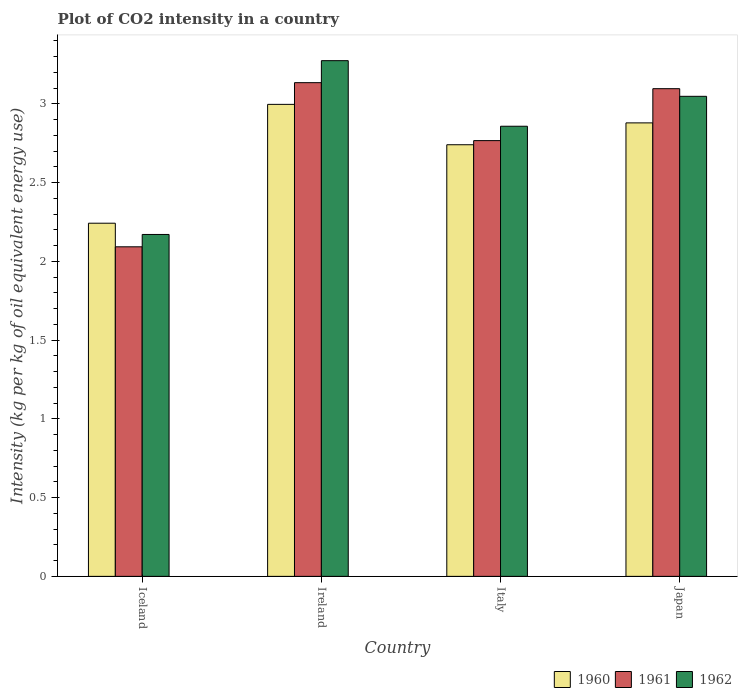How many different coloured bars are there?
Ensure brevity in your answer.  3. How many groups of bars are there?
Provide a short and direct response. 4. Are the number of bars per tick equal to the number of legend labels?
Your answer should be very brief. Yes. Are the number of bars on each tick of the X-axis equal?
Ensure brevity in your answer.  Yes. How many bars are there on the 2nd tick from the right?
Ensure brevity in your answer.  3. What is the label of the 4th group of bars from the left?
Ensure brevity in your answer.  Japan. In how many cases, is the number of bars for a given country not equal to the number of legend labels?
Keep it short and to the point. 0. What is the CO2 intensity in in 1962 in Japan?
Offer a very short reply. 3.05. Across all countries, what is the maximum CO2 intensity in in 1961?
Give a very brief answer. 3.14. Across all countries, what is the minimum CO2 intensity in in 1960?
Keep it short and to the point. 2.24. In which country was the CO2 intensity in in 1960 maximum?
Your answer should be very brief. Ireland. In which country was the CO2 intensity in in 1960 minimum?
Provide a short and direct response. Iceland. What is the total CO2 intensity in in 1962 in the graph?
Keep it short and to the point. 11.35. What is the difference between the CO2 intensity in in 1960 in Iceland and that in Italy?
Offer a very short reply. -0.5. What is the difference between the CO2 intensity in in 1960 in Japan and the CO2 intensity in in 1961 in Ireland?
Keep it short and to the point. -0.26. What is the average CO2 intensity in in 1960 per country?
Ensure brevity in your answer.  2.72. What is the difference between the CO2 intensity in of/in 1962 and CO2 intensity in of/in 1960 in Iceland?
Keep it short and to the point. -0.07. In how many countries, is the CO2 intensity in in 1960 greater than 1.8 kg?
Ensure brevity in your answer.  4. What is the ratio of the CO2 intensity in in 1960 in Ireland to that in Japan?
Ensure brevity in your answer.  1.04. What is the difference between the highest and the second highest CO2 intensity in in 1960?
Offer a terse response. 0.12. What is the difference between the highest and the lowest CO2 intensity in in 1960?
Provide a short and direct response. 0.75. Is the sum of the CO2 intensity in in 1960 in Iceland and Italy greater than the maximum CO2 intensity in in 1961 across all countries?
Your response must be concise. Yes. What does the 2nd bar from the left in Italy represents?
Make the answer very short. 1961. Is it the case that in every country, the sum of the CO2 intensity in in 1960 and CO2 intensity in in 1961 is greater than the CO2 intensity in in 1962?
Give a very brief answer. Yes. Are all the bars in the graph horizontal?
Offer a terse response. No. How many countries are there in the graph?
Provide a succinct answer. 4. Does the graph contain grids?
Offer a terse response. No. Where does the legend appear in the graph?
Your answer should be very brief. Bottom right. How are the legend labels stacked?
Your answer should be very brief. Horizontal. What is the title of the graph?
Provide a short and direct response. Plot of CO2 intensity in a country. What is the label or title of the Y-axis?
Your response must be concise. Intensity (kg per kg of oil equivalent energy use). What is the Intensity (kg per kg of oil equivalent energy use) in 1960 in Iceland?
Provide a short and direct response. 2.24. What is the Intensity (kg per kg of oil equivalent energy use) in 1961 in Iceland?
Your answer should be compact. 2.09. What is the Intensity (kg per kg of oil equivalent energy use) of 1962 in Iceland?
Provide a short and direct response. 2.17. What is the Intensity (kg per kg of oil equivalent energy use) of 1960 in Ireland?
Provide a short and direct response. 3. What is the Intensity (kg per kg of oil equivalent energy use) in 1961 in Ireland?
Make the answer very short. 3.14. What is the Intensity (kg per kg of oil equivalent energy use) in 1962 in Ireland?
Keep it short and to the point. 3.27. What is the Intensity (kg per kg of oil equivalent energy use) in 1960 in Italy?
Give a very brief answer. 2.74. What is the Intensity (kg per kg of oil equivalent energy use) of 1961 in Italy?
Ensure brevity in your answer.  2.77. What is the Intensity (kg per kg of oil equivalent energy use) in 1962 in Italy?
Keep it short and to the point. 2.86. What is the Intensity (kg per kg of oil equivalent energy use) in 1960 in Japan?
Provide a succinct answer. 2.88. What is the Intensity (kg per kg of oil equivalent energy use) of 1961 in Japan?
Your response must be concise. 3.1. What is the Intensity (kg per kg of oil equivalent energy use) of 1962 in Japan?
Keep it short and to the point. 3.05. Across all countries, what is the maximum Intensity (kg per kg of oil equivalent energy use) of 1960?
Your answer should be compact. 3. Across all countries, what is the maximum Intensity (kg per kg of oil equivalent energy use) of 1961?
Provide a short and direct response. 3.14. Across all countries, what is the maximum Intensity (kg per kg of oil equivalent energy use) in 1962?
Give a very brief answer. 3.27. Across all countries, what is the minimum Intensity (kg per kg of oil equivalent energy use) in 1960?
Make the answer very short. 2.24. Across all countries, what is the minimum Intensity (kg per kg of oil equivalent energy use) of 1961?
Your response must be concise. 2.09. Across all countries, what is the minimum Intensity (kg per kg of oil equivalent energy use) of 1962?
Your answer should be compact. 2.17. What is the total Intensity (kg per kg of oil equivalent energy use) of 1960 in the graph?
Your answer should be very brief. 10.86. What is the total Intensity (kg per kg of oil equivalent energy use) in 1961 in the graph?
Ensure brevity in your answer.  11.09. What is the total Intensity (kg per kg of oil equivalent energy use) of 1962 in the graph?
Keep it short and to the point. 11.35. What is the difference between the Intensity (kg per kg of oil equivalent energy use) in 1960 in Iceland and that in Ireland?
Provide a short and direct response. -0.75. What is the difference between the Intensity (kg per kg of oil equivalent energy use) in 1961 in Iceland and that in Ireland?
Your answer should be very brief. -1.04. What is the difference between the Intensity (kg per kg of oil equivalent energy use) of 1962 in Iceland and that in Ireland?
Ensure brevity in your answer.  -1.1. What is the difference between the Intensity (kg per kg of oil equivalent energy use) in 1960 in Iceland and that in Italy?
Offer a terse response. -0.5. What is the difference between the Intensity (kg per kg of oil equivalent energy use) of 1961 in Iceland and that in Italy?
Ensure brevity in your answer.  -0.67. What is the difference between the Intensity (kg per kg of oil equivalent energy use) in 1962 in Iceland and that in Italy?
Your response must be concise. -0.69. What is the difference between the Intensity (kg per kg of oil equivalent energy use) in 1960 in Iceland and that in Japan?
Give a very brief answer. -0.64. What is the difference between the Intensity (kg per kg of oil equivalent energy use) in 1961 in Iceland and that in Japan?
Give a very brief answer. -1. What is the difference between the Intensity (kg per kg of oil equivalent energy use) of 1962 in Iceland and that in Japan?
Provide a short and direct response. -0.88. What is the difference between the Intensity (kg per kg of oil equivalent energy use) in 1960 in Ireland and that in Italy?
Your answer should be compact. 0.26. What is the difference between the Intensity (kg per kg of oil equivalent energy use) of 1961 in Ireland and that in Italy?
Your response must be concise. 0.37. What is the difference between the Intensity (kg per kg of oil equivalent energy use) in 1962 in Ireland and that in Italy?
Provide a succinct answer. 0.42. What is the difference between the Intensity (kg per kg of oil equivalent energy use) in 1960 in Ireland and that in Japan?
Give a very brief answer. 0.12. What is the difference between the Intensity (kg per kg of oil equivalent energy use) in 1961 in Ireland and that in Japan?
Ensure brevity in your answer.  0.04. What is the difference between the Intensity (kg per kg of oil equivalent energy use) in 1962 in Ireland and that in Japan?
Provide a short and direct response. 0.23. What is the difference between the Intensity (kg per kg of oil equivalent energy use) of 1960 in Italy and that in Japan?
Your answer should be compact. -0.14. What is the difference between the Intensity (kg per kg of oil equivalent energy use) of 1961 in Italy and that in Japan?
Provide a short and direct response. -0.33. What is the difference between the Intensity (kg per kg of oil equivalent energy use) in 1962 in Italy and that in Japan?
Provide a succinct answer. -0.19. What is the difference between the Intensity (kg per kg of oil equivalent energy use) in 1960 in Iceland and the Intensity (kg per kg of oil equivalent energy use) in 1961 in Ireland?
Give a very brief answer. -0.89. What is the difference between the Intensity (kg per kg of oil equivalent energy use) of 1960 in Iceland and the Intensity (kg per kg of oil equivalent energy use) of 1962 in Ireland?
Offer a terse response. -1.03. What is the difference between the Intensity (kg per kg of oil equivalent energy use) of 1961 in Iceland and the Intensity (kg per kg of oil equivalent energy use) of 1962 in Ireland?
Provide a short and direct response. -1.18. What is the difference between the Intensity (kg per kg of oil equivalent energy use) of 1960 in Iceland and the Intensity (kg per kg of oil equivalent energy use) of 1961 in Italy?
Provide a short and direct response. -0.52. What is the difference between the Intensity (kg per kg of oil equivalent energy use) in 1960 in Iceland and the Intensity (kg per kg of oil equivalent energy use) in 1962 in Italy?
Offer a terse response. -0.62. What is the difference between the Intensity (kg per kg of oil equivalent energy use) in 1961 in Iceland and the Intensity (kg per kg of oil equivalent energy use) in 1962 in Italy?
Give a very brief answer. -0.77. What is the difference between the Intensity (kg per kg of oil equivalent energy use) of 1960 in Iceland and the Intensity (kg per kg of oil equivalent energy use) of 1961 in Japan?
Your answer should be very brief. -0.85. What is the difference between the Intensity (kg per kg of oil equivalent energy use) in 1960 in Iceland and the Intensity (kg per kg of oil equivalent energy use) in 1962 in Japan?
Make the answer very short. -0.81. What is the difference between the Intensity (kg per kg of oil equivalent energy use) of 1961 in Iceland and the Intensity (kg per kg of oil equivalent energy use) of 1962 in Japan?
Your answer should be compact. -0.96. What is the difference between the Intensity (kg per kg of oil equivalent energy use) in 1960 in Ireland and the Intensity (kg per kg of oil equivalent energy use) in 1961 in Italy?
Ensure brevity in your answer.  0.23. What is the difference between the Intensity (kg per kg of oil equivalent energy use) of 1960 in Ireland and the Intensity (kg per kg of oil equivalent energy use) of 1962 in Italy?
Make the answer very short. 0.14. What is the difference between the Intensity (kg per kg of oil equivalent energy use) in 1961 in Ireland and the Intensity (kg per kg of oil equivalent energy use) in 1962 in Italy?
Your answer should be very brief. 0.28. What is the difference between the Intensity (kg per kg of oil equivalent energy use) in 1960 in Ireland and the Intensity (kg per kg of oil equivalent energy use) in 1961 in Japan?
Provide a short and direct response. -0.1. What is the difference between the Intensity (kg per kg of oil equivalent energy use) of 1960 in Ireland and the Intensity (kg per kg of oil equivalent energy use) of 1962 in Japan?
Your response must be concise. -0.05. What is the difference between the Intensity (kg per kg of oil equivalent energy use) of 1961 in Ireland and the Intensity (kg per kg of oil equivalent energy use) of 1962 in Japan?
Your answer should be compact. 0.09. What is the difference between the Intensity (kg per kg of oil equivalent energy use) in 1960 in Italy and the Intensity (kg per kg of oil equivalent energy use) in 1961 in Japan?
Offer a very short reply. -0.36. What is the difference between the Intensity (kg per kg of oil equivalent energy use) in 1960 in Italy and the Intensity (kg per kg of oil equivalent energy use) in 1962 in Japan?
Make the answer very short. -0.31. What is the difference between the Intensity (kg per kg of oil equivalent energy use) in 1961 in Italy and the Intensity (kg per kg of oil equivalent energy use) in 1962 in Japan?
Your answer should be very brief. -0.28. What is the average Intensity (kg per kg of oil equivalent energy use) in 1960 per country?
Make the answer very short. 2.72. What is the average Intensity (kg per kg of oil equivalent energy use) in 1961 per country?
Offer a terse response. 2.77. What is the average Intensity (kg per kg of oil equivalent energy use) in 1962 per country?
Provide a succinct answer. 2.84. What is the difference between the Intensity (kg per kg of oil equivalent energy use) of 1960 and Intensity (kg per kg of oil equivalent energy use) of 1961 in Iceland?
Your answer should be compact. 0.15. What is the difference between the Intensity (kg per kg of oil equivalent energy use) in 1960 and Intensity (kg per kg of oil equivalent energy use) in 1962 in Iceland?
Ensure brevity in your answer.  0.07. What is the difference between the Intensity (kg per kg of oil equivalent energy use) in 1961 and Intensity (kg per kg of oil equivalent energy use) in 1962 in Iceland?
Give a very brief answer. -0.08. What is the difference between the Intensity (kg per kg of oil equivalent energy use) in 1960 and Intensity (kg per kg of oil equivalent energy use) in 1961 in Ireland?
Offer a terse response. -0.14. What is the difference between the Intensity (kg per kg of oil equivalent energy use) of 1960 and Intensity (kg per kg of oil equivalent energy use) of 1962 in Ireland?
Provide a succinct answer. -0.28. What is the difference between the Intensity (kg per kg of oil equivalent energy use) of 1961 and Intensity (kg per kg of oil equivalent energy use) of 1962 in Ireland?
Make the answer very short. -0.14. What is the difference between the Intensity (kg per kg of oil equivalent energy use) in 1960 and Intensity (kg per kg of oil equivalent energy use) in 1961 in Italy?
Make the answer very short. -0.03. What is the difference between the Intensity (kg per kg of oil equivalent energy use) in 1960 and Intensity (kg per kg of oil equivalent energy use) in 1962 in Italy?
Keep it short and to the point. -0.12. What is the difference between the Intensity (kg per kg of oil equivalent energy use) in 1961 and Intensity (kg per kg of oil equivalent energy use) in 1962 in Italy?
Provide a short and direct response. -0.09. What is the difference between the Intensity (kg per kg of oil equivalent energy use) in 1960 and Intensity (kg per kg of oil equivalent energy use) in 1961 in Japan?
Make the answer very short. -0.22. What is the difference between the Intensity (kg per kg of oil equivalent energy use) of 1960 and Intensity (kg per kg of oil equivalent energy use) of 1962 in Japan?
Give a very brief answer. -0.17. What is the difference between the Intensity (kg per kg of oil equivalent energy use) in 1961 and Intensity (kg per kg of oil equivalent energy use) in 1962 in Japan?
Your answer should be compact. 0.05. What is the ratio of the Intensity (kg per kg of oil equivalent energy use) of 1960 in Iceland to that in Ireland?
Offer a very short reply. 0.75. What is the ratio of the Intensity (kg per kg of oil equivalent energy use) in 1961 in Iceland to that in Ireland?
Your answer should be very brief. 0.67. What is the ratio of the Intensity (kg per kg of oil equivalent energy use) in 1962 in Iceland to that in Ireland?
Offer a very short reply. 0.66. What is the ratio of the Intensity (kg per kg of oil equivalent energy use) in 1960 in Iceland to that in Italy?
Your answer should be very brief. 0.82. What is the ratio of the Intensity (kg per kg of oil equivalent energy use) in 1961 in Iceland to that in Italy?
Keep it short and to the point. 0.76. What is the ratio of the Intensity (kg per kg of oil equivalent energy use) in 1962 in Iceland to that in Italy?
Keep it short and to the point. 0.76. What is the ratio of the Intensity (kg per kg of oil equivalent energy use) in 1960 in Iceland to that in Japan?
Your answer should be compact. 0.78. What is the ratio of the Intensity (kg per kg of oil equivalent energy use) of 1961 in Iceland to that in Japan?
Offer a terse response. 0.68. What is the ratio of the Intensity (kg per kg of oil equivalent energy use) in 1962 in Iceland to that in Japan?
Provide a succinct answer. 0.71. What is the ratio of the Intensity (kg per kg of oil equivalent energy use) in 1960 in Ireland to that in Italy?
Provide a succinct answer. 1.09. What is the ratio of the Intensity (kg per kg of oil equivalent energy use) in 1961 in Ireland to that in Italy?
Your response must be concise. 1.13. What is the ratio of the Intensity (kg per kg of oil equivalent energy use) of 1962 in Ireland to that in Italy?
Provide a short and direct response. 1.15. What is the ratio of the Intensity (kg per kg of oil equivalent energy use) in 1960 in Ireland to that in Japan?
Your response must be concise. 1.04. What is the ratio of the Intensity (kg per kg of oil equivalent energy use) of 1961 in Ireland to that in Japan?
Provide a succinct answer. 1.01. What is the ratio of the Intensity (kg per kg of oil equivalent energy use) of 1962 in Ireland to that in Japan?
Your answer should be very brief. 1.07. What is the ratio of the Intensity (kg per kg of oil equivalent energy use) of 1960 in Italy to that in Japan?
Keep it short and to the point. 0.95. What is the ratio of the Intensity (kg per kg of oil equivalent energy use) of 1961 in Italy to that in Japan?
Your response must be concise. 0.89. What is the ratio of the Intensity (kg per kg of oil equivalent energy use) in 1962 in Italy to that in Japan?
Your answer should be very brief. 0.94. What is the difference between the highest and the second highest Intensity (kg per kg of oil equivalent energy use) of 1960?
Give a very brief answer. 0.12. What is the difference between the highest and the second highest Intensity (kg per kg of oil equivalent energy use) in 1961?
Provide a succinct answer. 0.04. What is the difference between the highest and the second highest Intensity (kg per kg of oil equivalent energy use) in 1962?
Your answer should be compact. 0.23. What is the difference between the highest and the lowest Intensity (kg per kg of oil equivalent energy use) of 1960?
Provide a short and direct response. 0.75. What is the difference between the highest and the lowest Intensity (kg per kg of oil equivalent energy use) of 1961?
Keep it short and to the point. 1.04. What is the difference between the highest and the lowest Intensity (kg per kg of oil equivalent energy use) of 1962?
Your answer should be very brief. 1.1. 